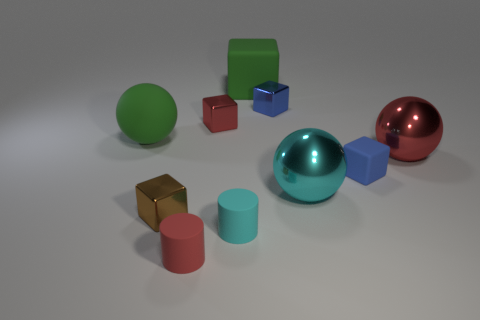Are there the same number of cyan matte cylinders that are to the left of the brown metallic cube and small gray objects?
Offer a very short reply. Yes. Are there any other things that have the same material as the tiny brown block?
Provide a short and direct response. Yes. How many big objects are either red rubber cylinders or gray spheres?
Keep it short and to the point. 0. There is a large matte thing that is the same color as the large rubber ball; what shape is it?
Provide a short and direct response. Cube. Is the large thing right of the cyan shiny thing made of the same material as the cyan cylinder?
Make the answer very short. No. Is the number of small cyan rubber things the same as the number of small red balls?
Your answer should be compact. No. What is the material of the blue object that is in front of the shiny ball that is behind the small blue matte object?
Keep it short and to the point. Rubber. What number of big green matte things are the same shape as the large red metal object?
Your response must be concise. 1. How big is the matte cube in front of the red metallic thing that is to the right of the large green rubber object that is behind the large green ball?
Your answer should be very brief. Small. How many cyan objects are either big matte balls or tiny metallic things?
Keep it short and to the point. 0. 